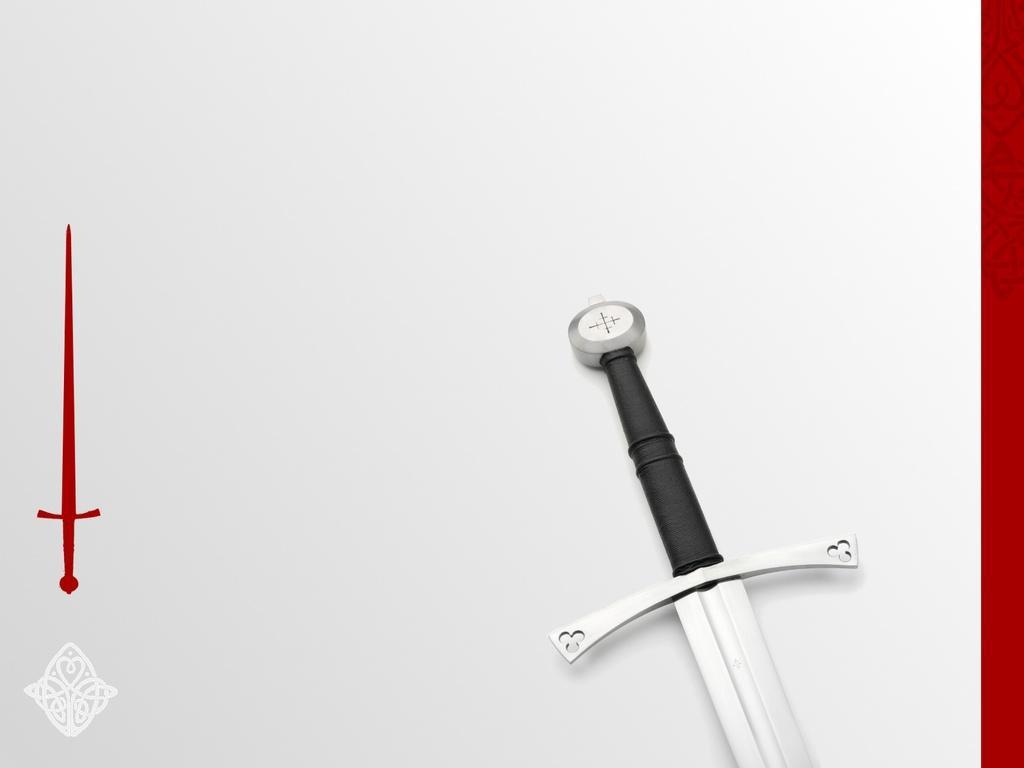What object can be seen on a surface in the image? There is a sword on a surface in the image. What else is present in the image related to a sword? There is a painting of a red sword at the left side of the image. What type of cheese is being used to sharpen the sword in the image? There is no cheese present in the image, and the sword is not being sharpened. 